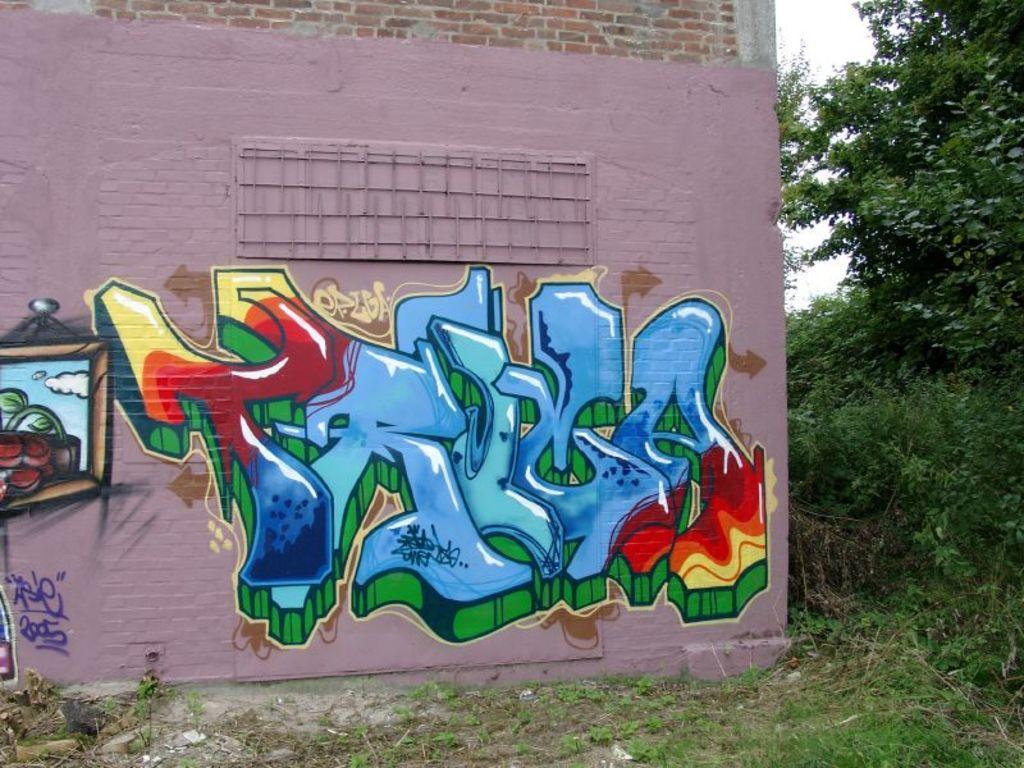Please provide a concise description of this image. This image consists of a wall on which there is a paining. At the bottom, there is green grass on the ground. To the right, there are trees. 